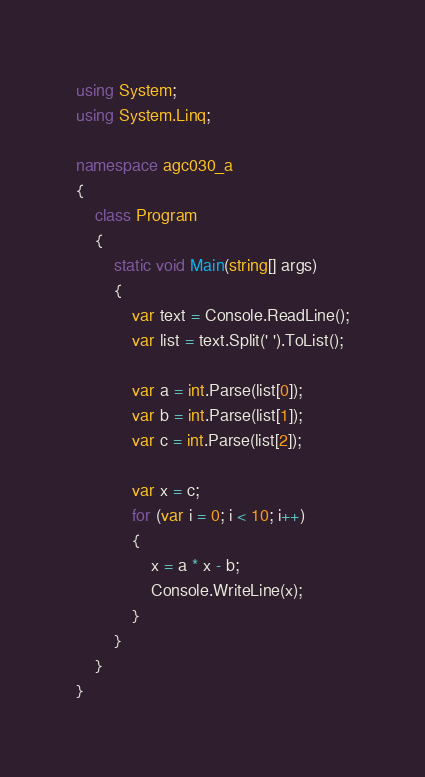<code> <loc_0><loc_0><loc_500><loc_500><_C#_>using System;
using System.Linq;

namespace agc030_a
{
    class Program
    {
        static void Main(string[] args)
        {
            var text = Console.ReadLine();
            var list = text.Split(' ').ToList();

            var a = int.Parse(list[0]);
            var b = int.Parse(list[1]);
            var c = int.Parse(list[2]);

            var x = c;
            for (var i = 0; i < 10; i++)
            {
                x = a * x - b;
                Console.WriteLine(x);
            }
        }
    }
}
</code> 